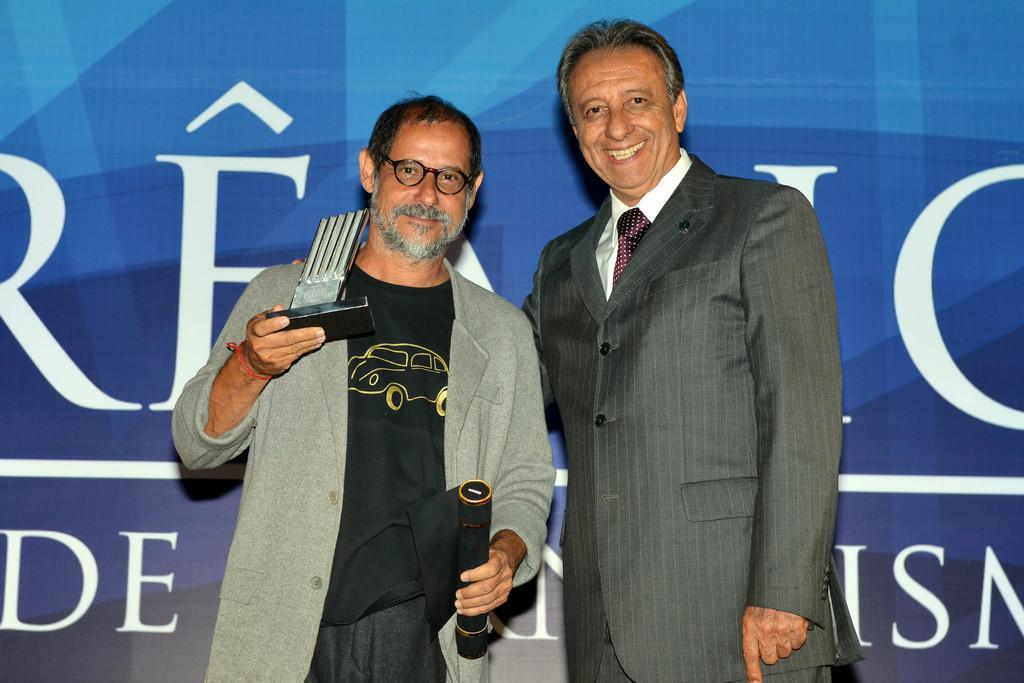In one or two sentences, can you explain what this image depicts? In the background there is a banner. We can see men standing and smiling. On the left side we can see a man, holding objects in his hands. 